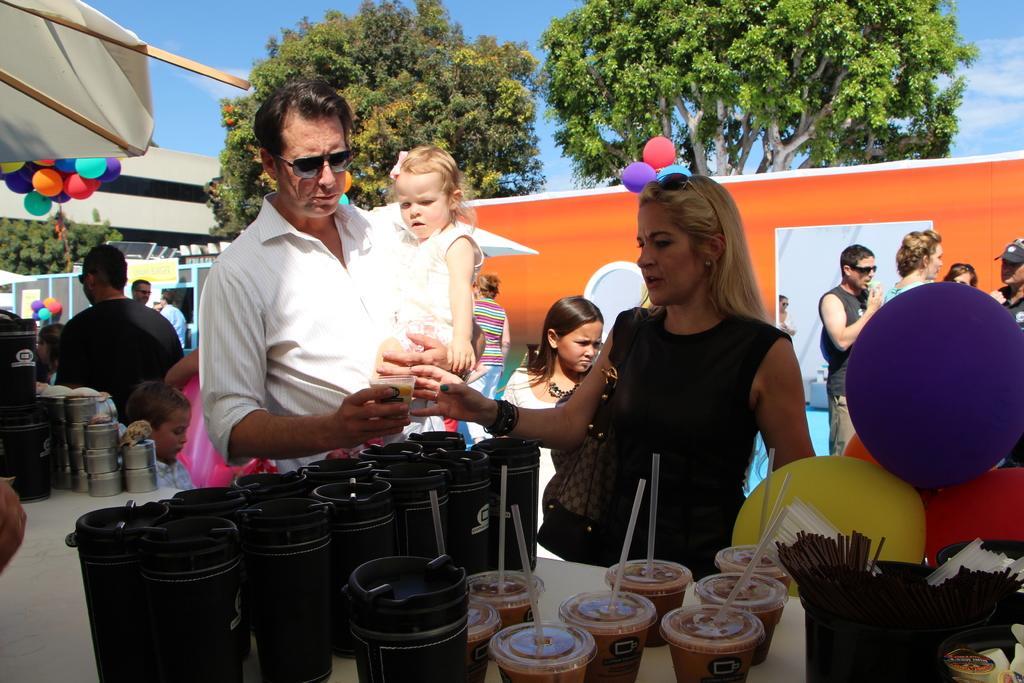Describe this image in one or two sentences. In this image I can see a group of people. In front I can see one person is holding something. I can see few black bottles, straws and few objects on the table. Back I can see few trees, orange board and colorful balloons. The sky is in blue and white color. 